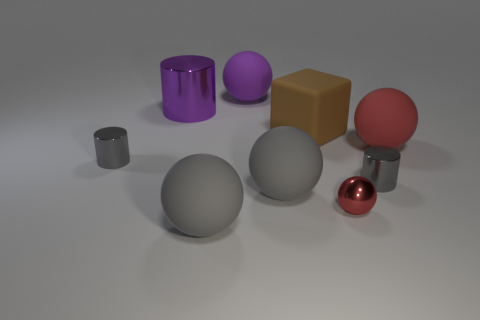Subtract all purple cylinders. How many cylinders are left? 2 Subtract all brown cubes. How many gray cylinders are left? 2 Subtract 3 balls. How many balls are left? 2 Add 1 large brown objects. How many objects exist? 10 Subtract all gray balls. How many balls are left? 3 Subtract all purple spheres. Subtract all purple cylinders. How many spheres are left? 4 Subtract all blocks. How many objects are left? 8 Add 7 yellow metallic objects. How many yellow metallic objects exist? 7 Subtract 0 brown cylinders. How many objects are left? 9 Subtract all large purple shiny cylinders. Subtract all green rubber things. How many objects are left? 8 